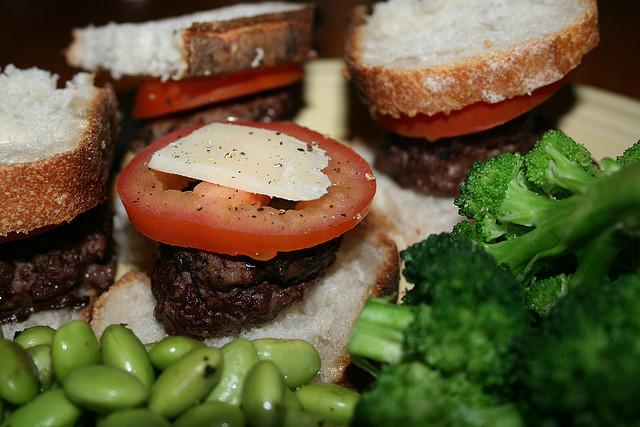What is on the tomato?
Give a very brief answer. Cheese. What color is the broccoli?
Write a very short answer. Green. What type of food is in the photo?
Keep it brief. Hamburger. 